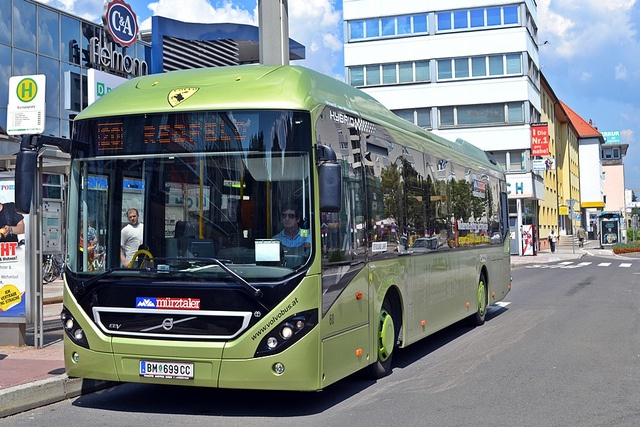Describe the objects in this image and their specific colors. I can see bus in gray, black, olive, and darkgray tones, people in gray, black, blue, and navy tones, people in gray, darkgray, and lightgray tones, people in gray and black tones, and people in gray, maroon, black, and darkgray tones in this image. 